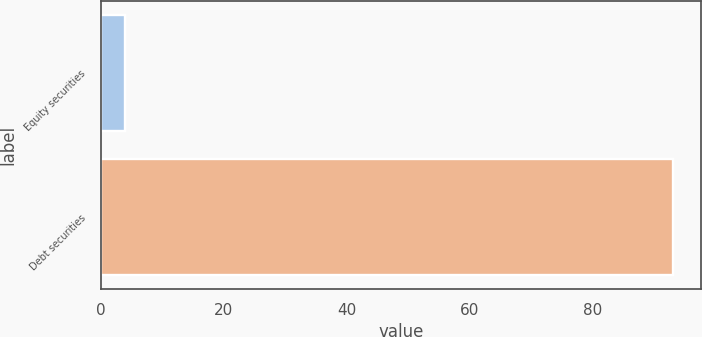Convert chart to OTSL. <chart><loc_0><loc_0><loc_500><loc_500><bar_chart><fcel>Equity securities<fcel>Debt securities<nl><fcel>4<fcel>93<nl></chart> 